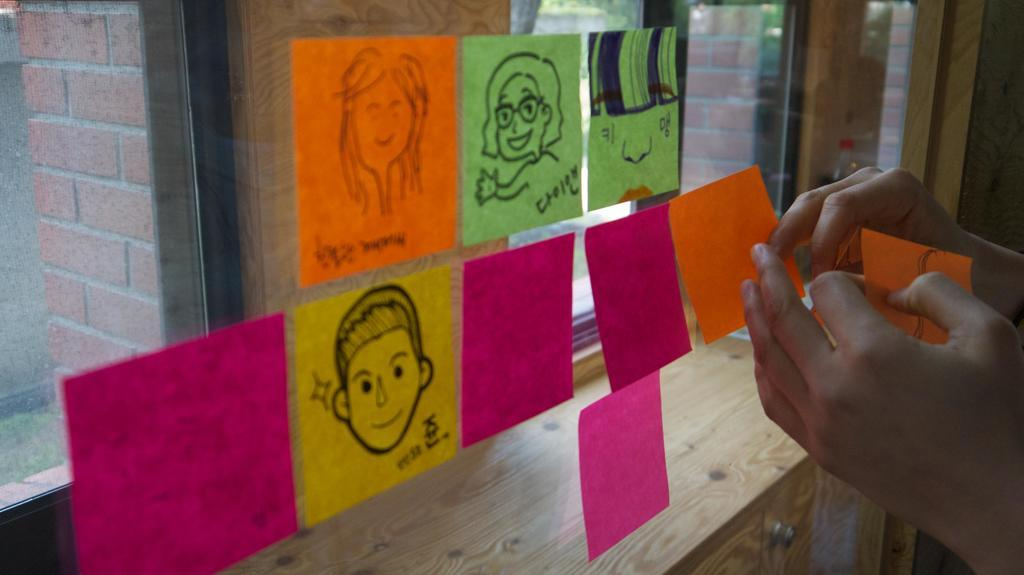What is the main object in the center of the image? There is a glass in the center of the image. What is covering the glass? Papers are pasted on the glass. Can you describe any human presence in the image? There is a person's hand at the right side of the image. What type of poison is visible on the papers pasted on the glass? There is no poison visible on the papers pasted on the glass; the image only shows papers covering the glass. 